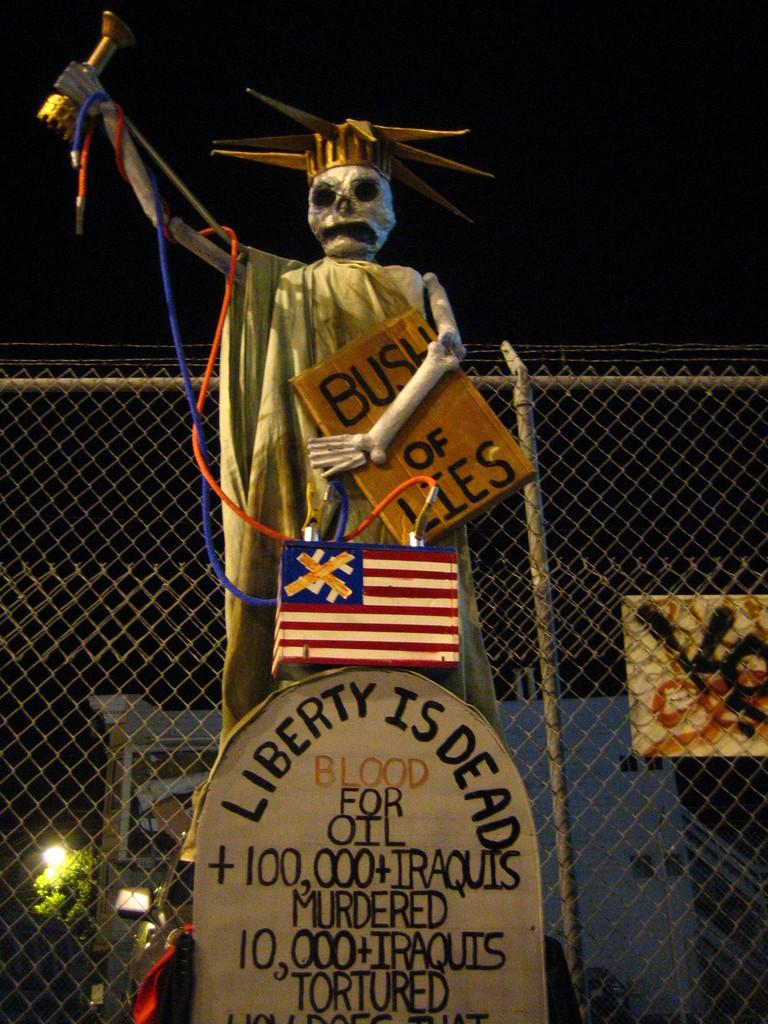What is the main subject in the center of the image? There is a statue in the center of the image. What is located at the bottom of the image? There is a board at the bottom of the image. What can be seen in the background of the image? There is a fence, a building, a tree, and a light in the background of the image. How many visitors are present in the image? There is no indication of any visitors in the image; it primarily features a statue, a board, and various background elements. 